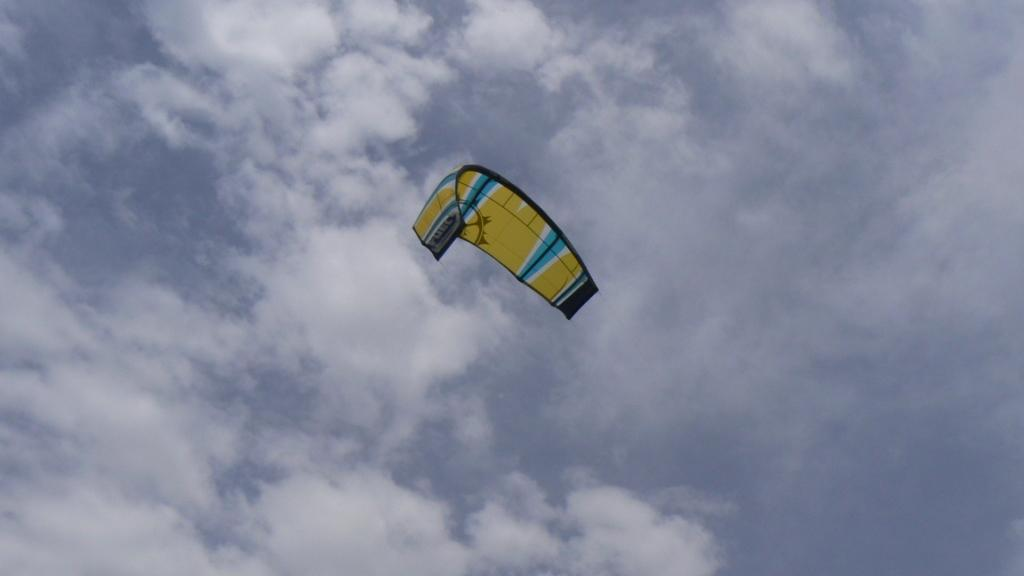What is the main object in the image? There is a parachute in the image. What colors are visible on the parachute? The parachute is in yellow and blue colors. What is the parachute doing in the image? The parachute is flying in the air. What can be seen in the background of the image? There is a sky visible in the background of the image. What is the condition of the sky in the image? There are clouds in the sky. What rate is the desk being processed at in the image? There is no desk present in the image, and therefore no rate or process can be observed. 